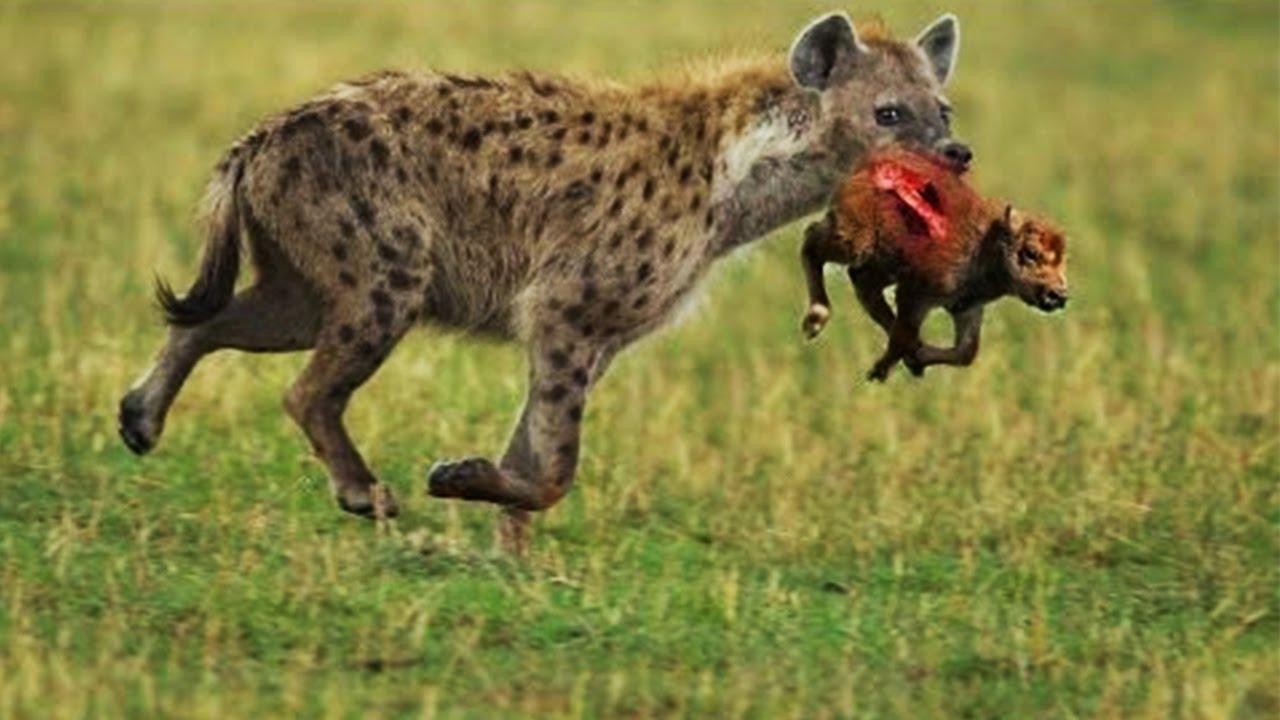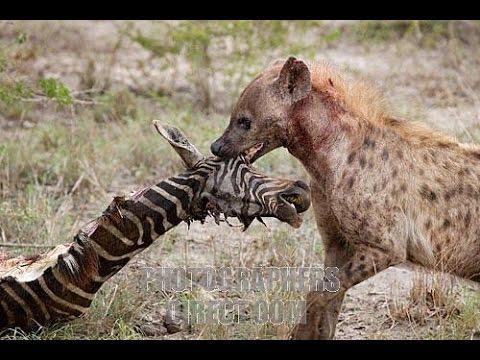The first image is the image on the left, the second image is the image on the right. For the images displayed, is the sentence "The right image shows at least one hyena grasping at a zebra carcass with its black and white striped hide still partly intact." factually correct? Answer yes or no. Yes. The first image is the image on the left, the second image is the image on the right. Examine the images to the left and right. Is the description "The left image contains one hyena with its teeth exposed and their tongue hanging out." accurate? Answer yes or no. No. 